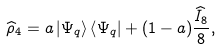<formula> <loc_0><loc_0><loc_500><loc_500>\widehat { \rho } _ { 4 } = a \left | \Psi _ { q } \right \rangle \left \langle \Psi _ { q } \right | + ( 1 - a ) \frac { \widehat { I } _ { 8 } } { 8 } ,</formula> 